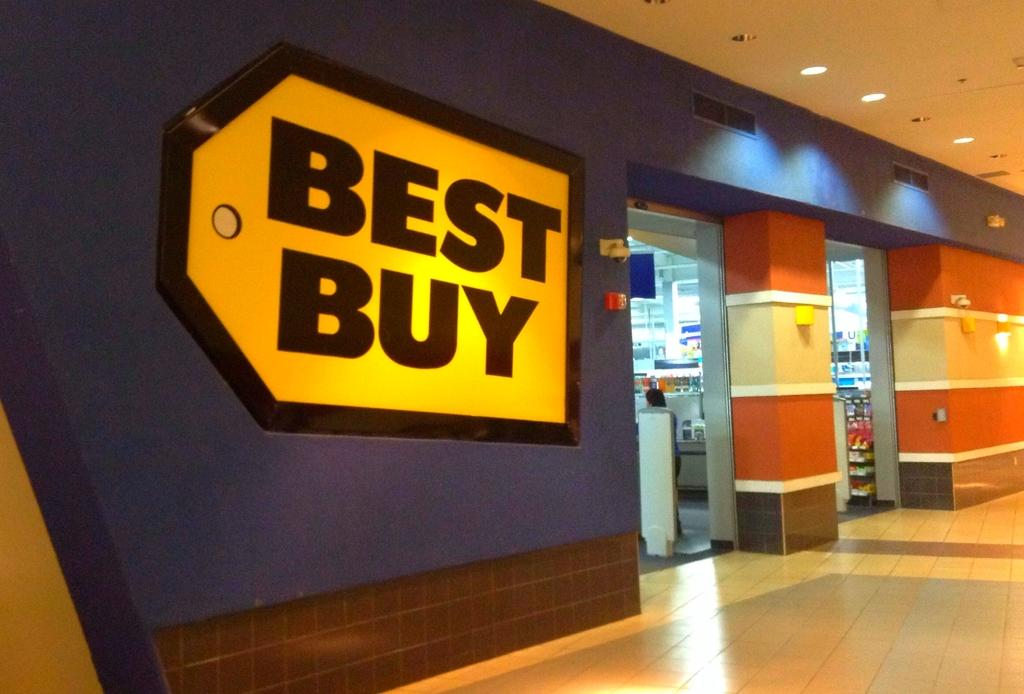<image>
Share a concise interpretation of the image provided. Best buy store that sell electronics and more 